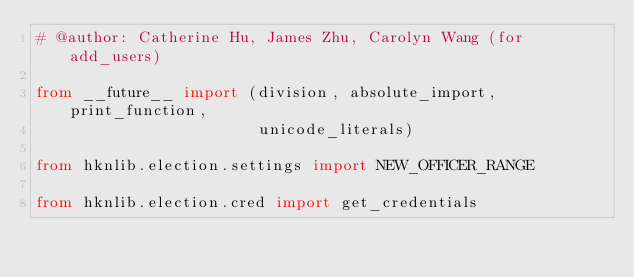Convert code to text. <code><loc_0><loc_0><loc_500><loc_500><_Python_># @author: Catherine Hu, James Zhu, Carolyn Wang (for add_users)

from __future__ import (division, absolute_import, print_function,
                        unicode_literals)

from hknlib.election.settings import NEW_OFFICER_RANGE

from hknlib.election.cred import get_credentials</code> 